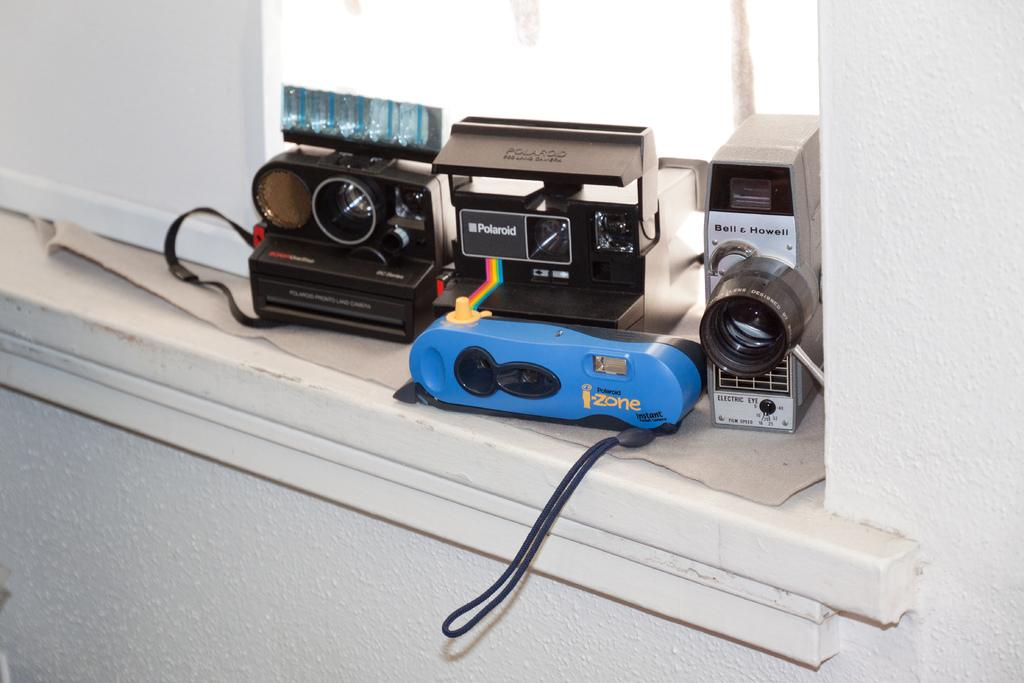What is the main object in the image? There is a table in the image. What is placed on the table? The table has different types of cameras on it. What type of oil can be seen dripping from the cameras in the image? There is no oil present in the image, and the cameras are not depicted as dripping anything. 